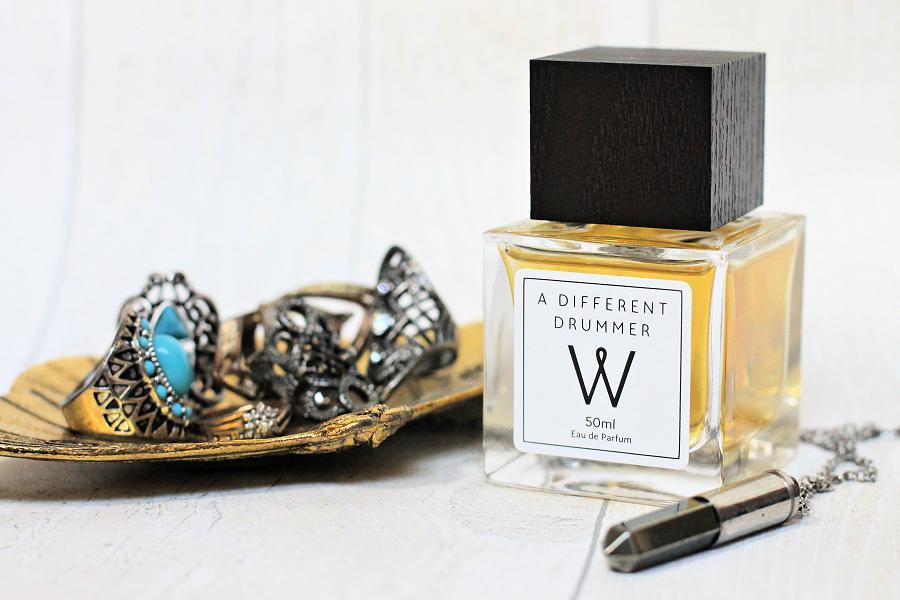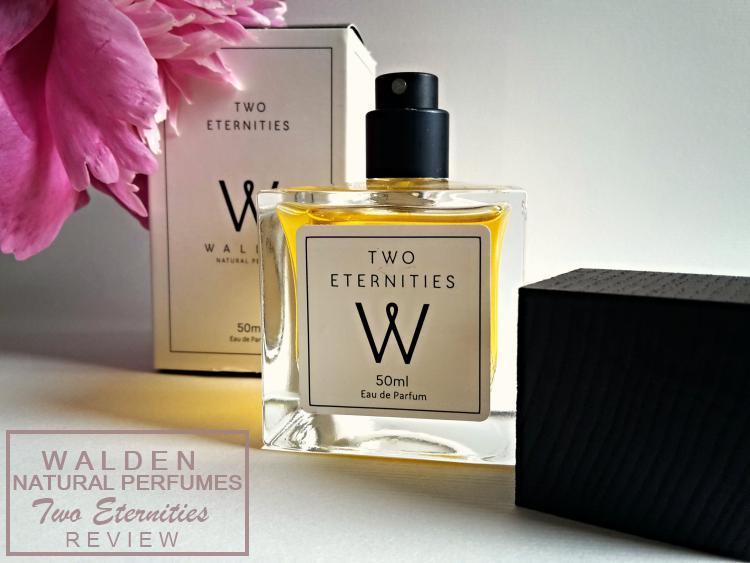The first image is the image on the left, the second image is the image on the right. For the images displayed, is the sentence "In one image, a square shaped spray bottle of cologne has its cap off and positioned to the side of the bottle, while a second image shows a similar square bottle with the cap on." factually correct? Answer yes or no. Yes. The first image is the image on the left, the second image is the image on the right. Assess this claim about the two images: "A pink flower is on the left of an image containing a square bottled fragrance and its upright box.". Correct or not? Answer yes or no. Yes. 